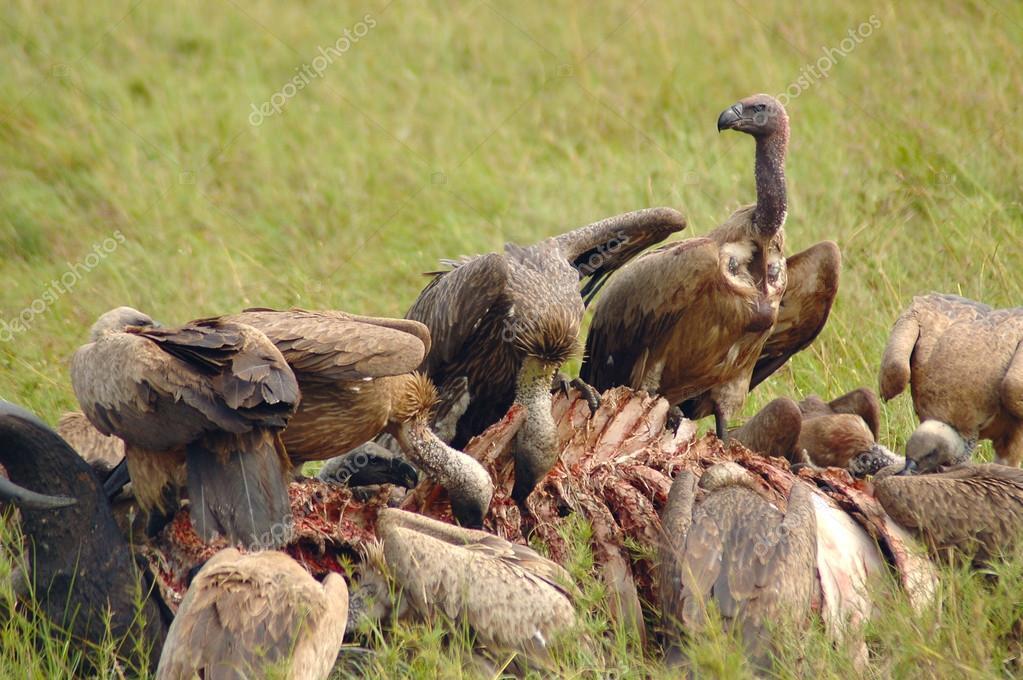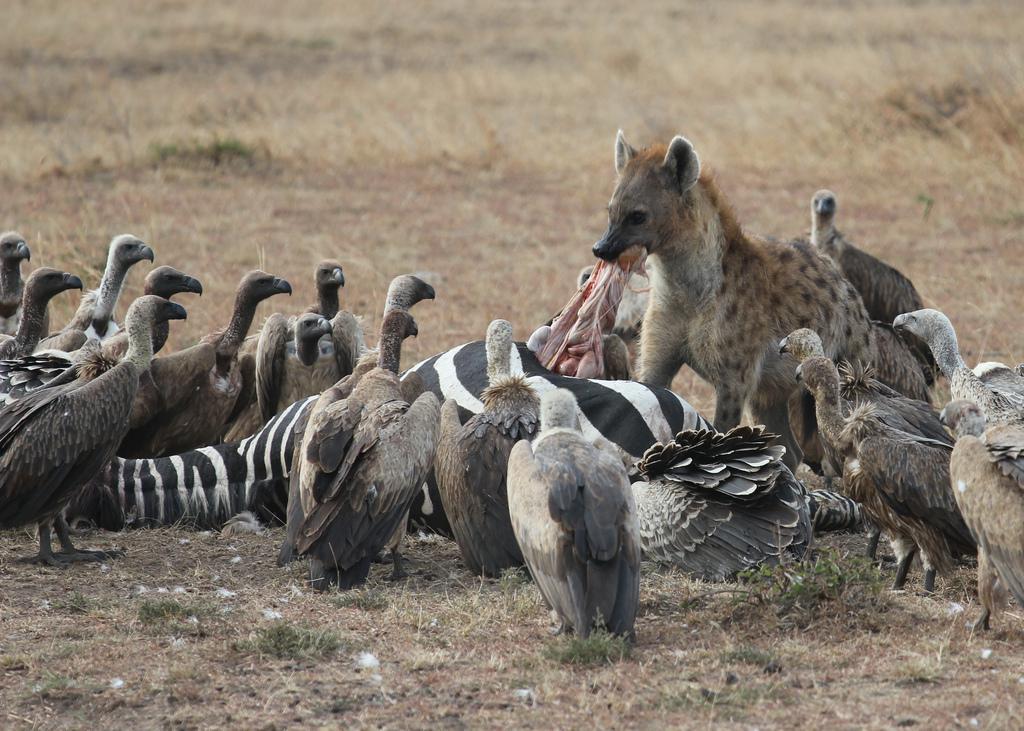The first image is the image on the left, the second image is the image on the right. Considering the images on both sides, is "An image shows vultures around a zebra carcass with some of its striped hide visible." valid? Answer yes or no. Yes. The first image is the image on the left, the second image is the image on the right. For the images displayed, is the sentence "The birds can be seen picking at the striped fur and remains of a zebra in one of the images." factually correct? Answer yes or no. Yes. 